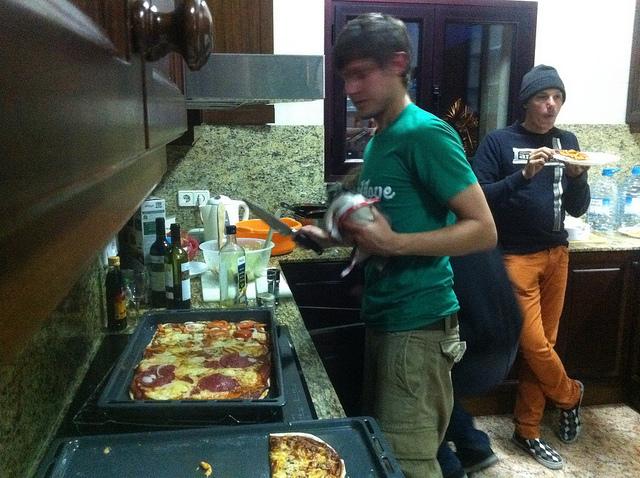Where is the chef knife?
Quick response, please. In hand. Is this indoors?
Answer briefly. Yes. What is the man with the orange pants eating?
Quick response, please. Pizza. 